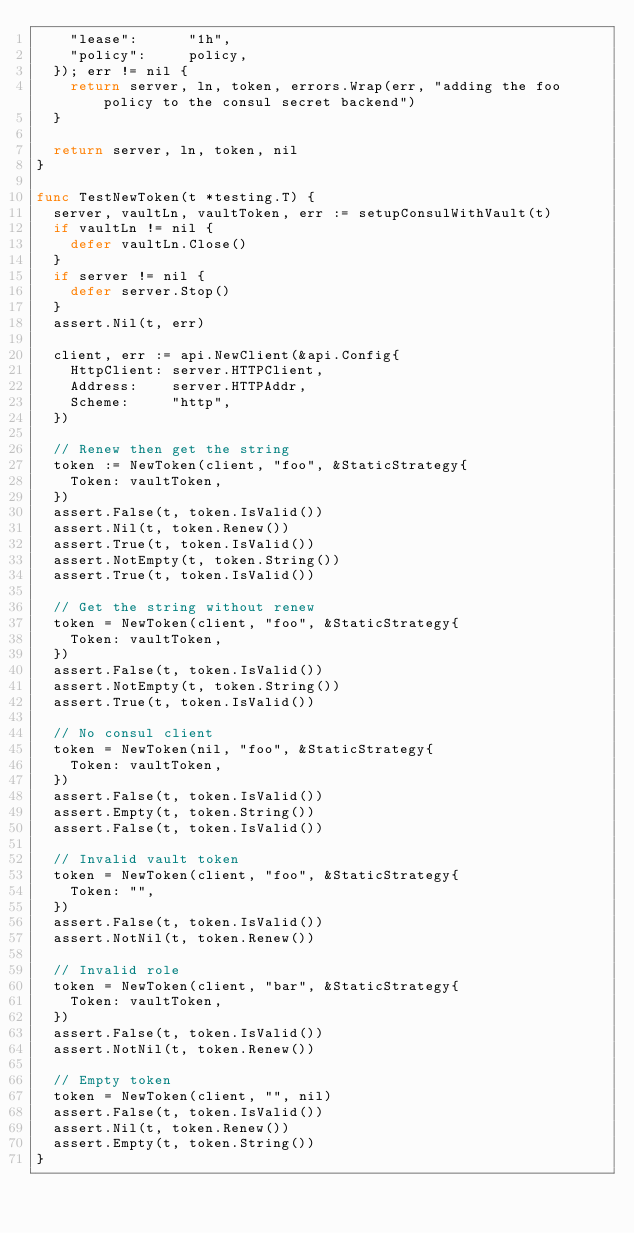<code> <loc_0><loc_0><loc_500><loc_500><_Go_>		"lease":      "1h",
		"policy":     policy,
	}); err != nil {
		return server, ln, token, errors.Wrap(err, "adding the foo policy to the consul secret backend")
	}

	return server, ln, token, nil
}

func TestNewToken(t *testing.T) {
	server, vaultLn, vaultToken, err := setupConsulWithVault(t)
	if vaultLn != nil {
		defer vaultLn.Close()
	}
	if server != nil {
		defer server.Stop()
	}
	assert.Nil(t, err)

	client, err := api.NewClient(&api.Config{
		HttpClient: server.HTTPClient,
		Address:    server.HTTPAddr,
		Scheme:     "http",
	})

	// Renew then get the string
	token := NewToken(client, "foo", &StaticStrategy{
		Token: vaultToken,
	})
	assert.False(t, token.IsValid())
	assert.Nil(t, token.Renew())
	assert.True(t, token.IsValid())
	assert.NotEmpty(t, token.String())
	assert.True(t, token.IsValid())

	// Get the string without renew
	token = NewToken(client, "foo", &StaticStrategy{
		Token: vaultToken,
	})
	assert.False(t, token.IsValid())
	assert.NotEmpty(t, token.String())
	assert.True(t, token.IsValid())

	// No consul client
	token = NewToken(nil, "foo", &StaticStrategy{
		Token: vaultToken,
	})
	assert.False(t, token.IsValid())
	assert.Empty(t, token.String())
	assert.False(t, token.IsValid())

	// Invalid vault token
	token = NewToken(client, "foo", &StaticStrategy{
		Token: "",
	})
	assert.False(t, token.IsValid())
	assert.NotNil(t, token.Renew())

	// Invalid role
	token = NewToken(client, "bar", &StaticStrategy{
		Token: vaultToken,
	})
	assert.False(t, token.IsValid())
	assert.NotNil(t, token.Renew())

	// Empty token
	token = NewToken(client, "", nil)
	assert.False(t, token.IsValid())
	assert.Nil(t, token.Renew())
	assert.Empty(t, token.String())
}
</code> 